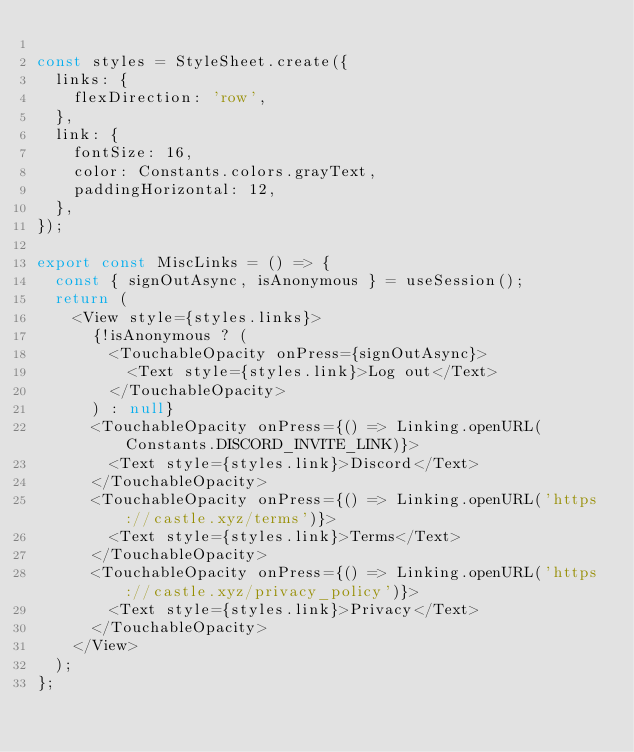Convert code to text. <code><loc_0><loc_0><loc_500><loc_500><_JavaScript_>
const styles = StyleSheet.create({
  links: {
    flexDirection: 'row',
  },
  link: {
    fontSize: 16,
    color: Constants.colors.grayText,
    paddingHorizontal: 12,
  },
});

export const MiscLinks = () => {
  const { signOutAsync, isAnonymous } = useSession();
  return (
    <View style={styles.links}>
      {!isAnonymous ? (
        <TouchableOpacity onPress={signOutAsync}>
          <Text style={styles.link}>Log out</Text>
        </TouchableOpacity>
      ) : null}
      <TouchableOpacity onPress={() => Linking.openURL(Constants.DISCORD_INVITE_LINK)}>
        <Text style={styles.link}>Discord</Text>
      </TouchableOpacity>
      <TouchableOpacity onPress={() => Linking.openURL('https://castle.xyz/terms')}>
        <Text style={styles.link}>Terms</Text>
      </TouchableOpacity>
      <TouchableOpacity onPress={() => Linking.openURL('https://castle.xyz/privacy_policy')}>
        <Text style={styles.link}>Privacy</Text>
      </TouchableOpacity>
    </View>
  );
};
</code> 